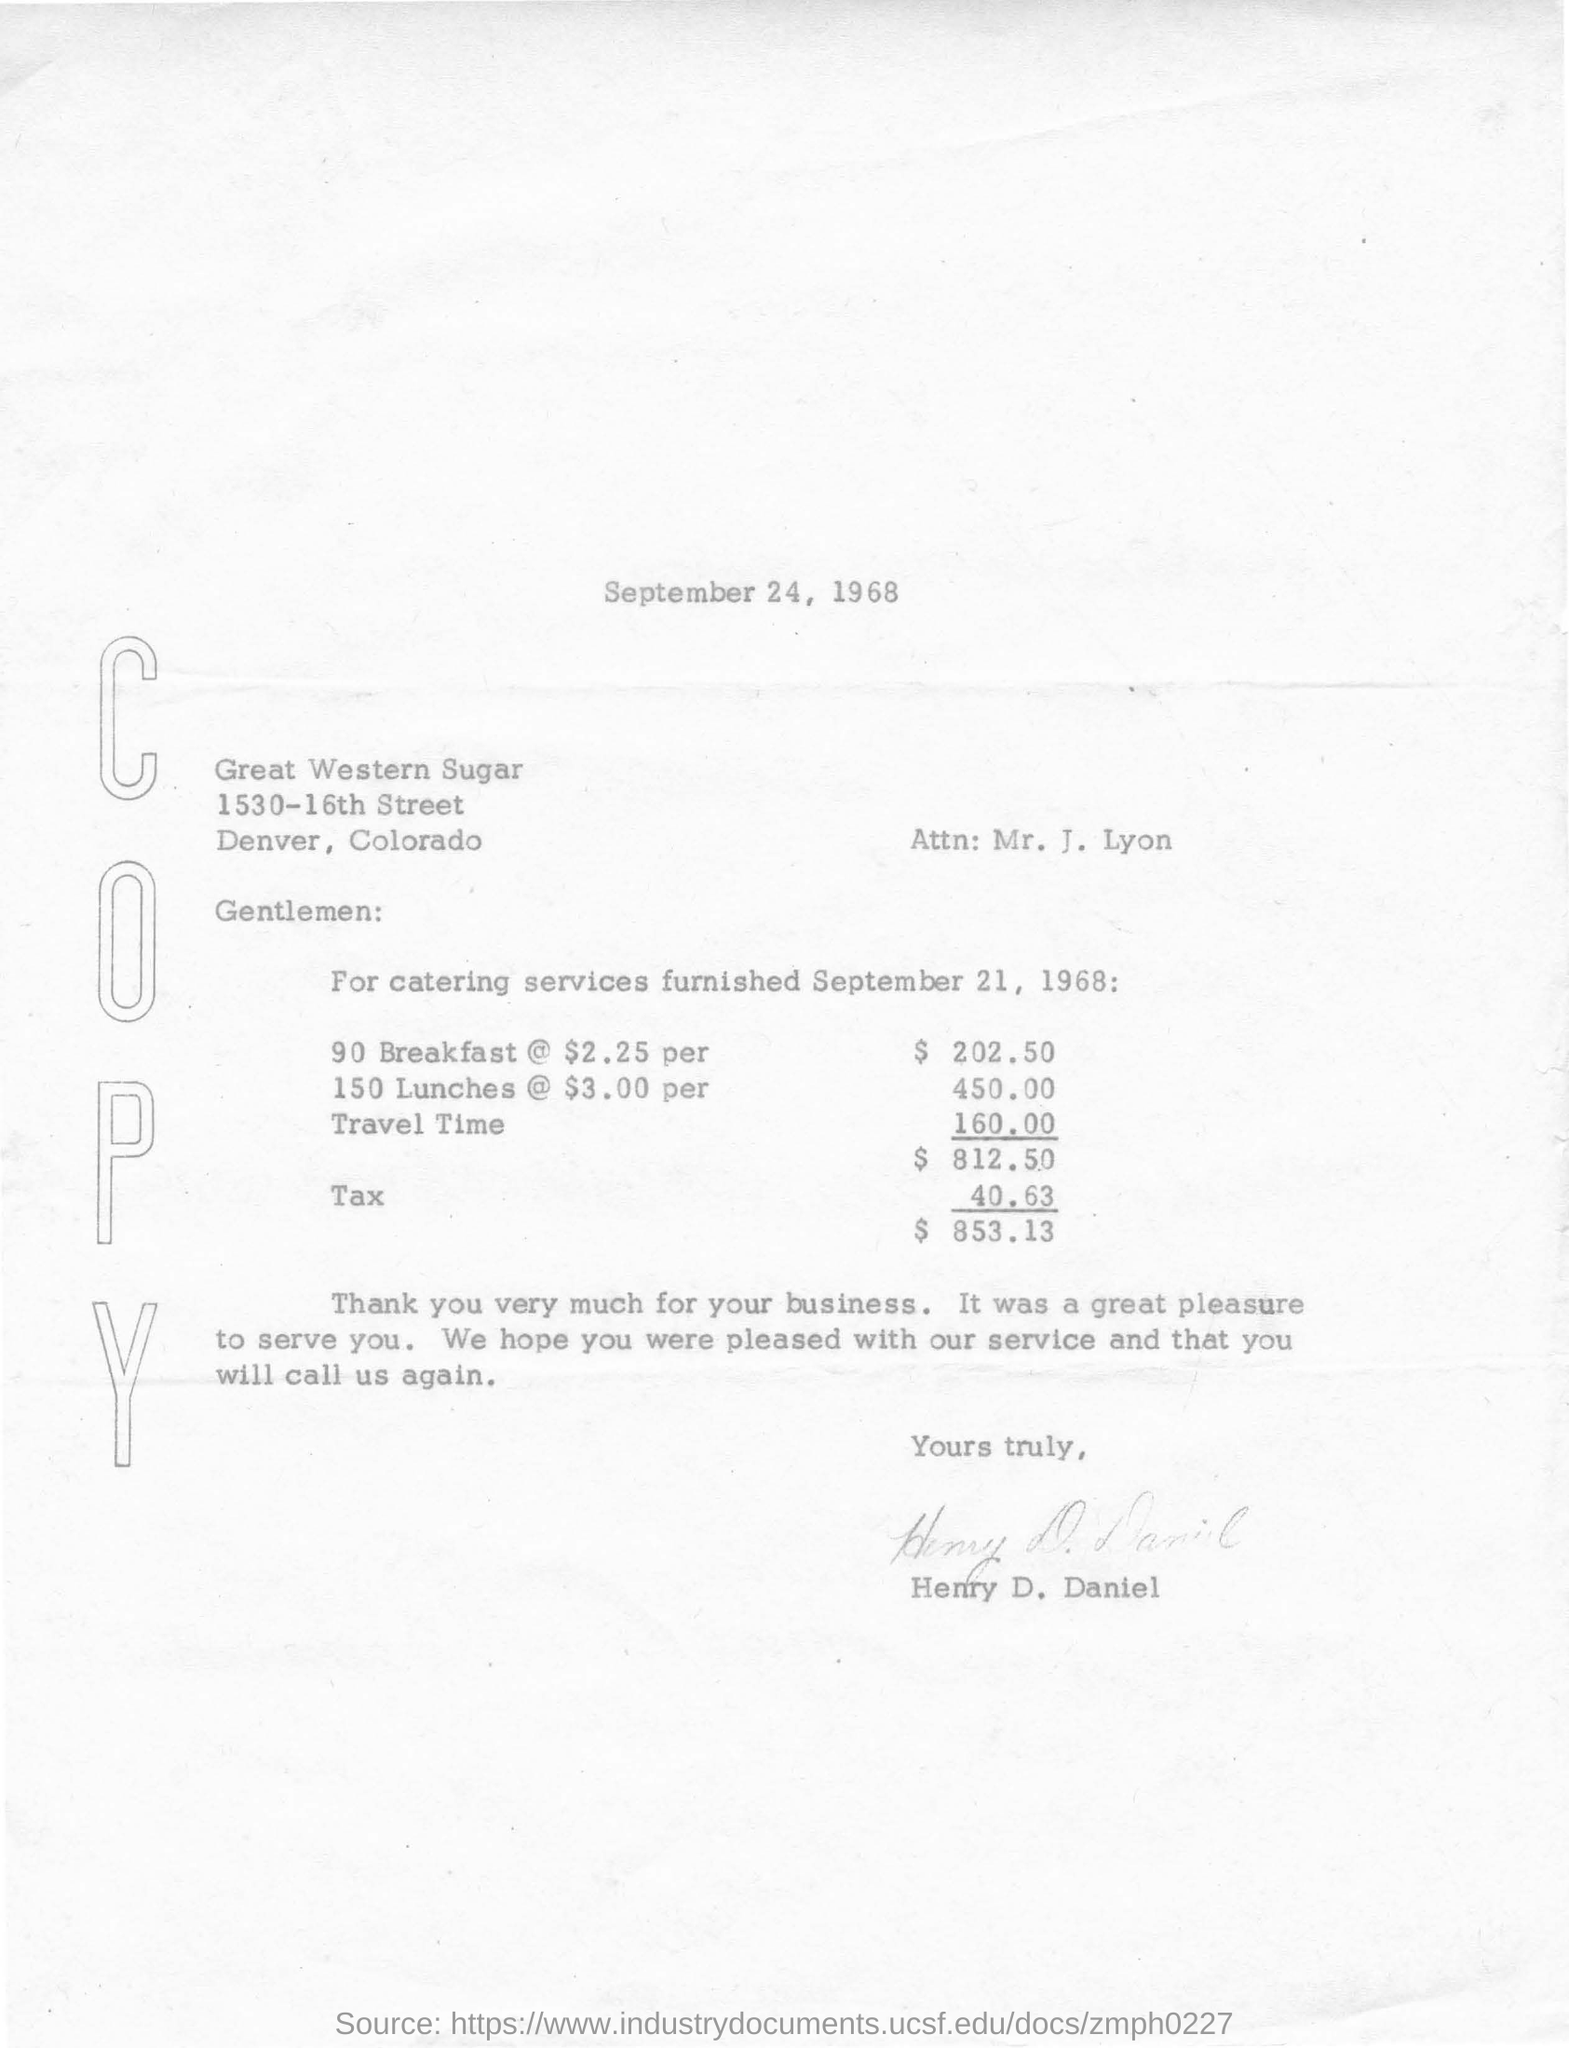Specify some key components in this picture. The date mentioned at the beginning of the document is September 24, 1968. 